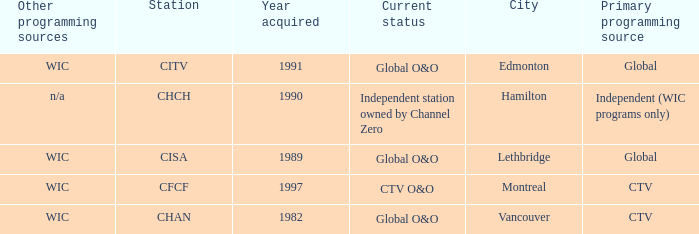Which station is located in edmonton CITV. 